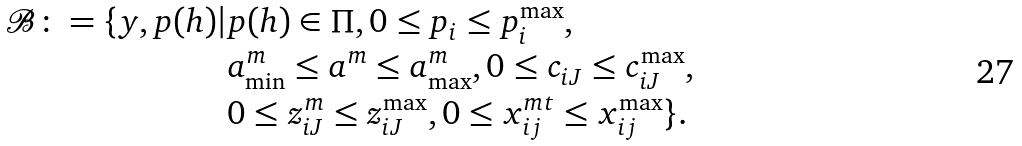Convert formula to latex. <formula><loc_0><loc_0><loc_500><loc_500>\mathcal { B } \colon = \{ y , p ( h ) | & p ( h ) \in \Pi , 0 \leq p _ { i } \leq p ^ { \max } _ { i } , \\ & a ^ { m } _ { \min } \leq a ^ { m } \leq a ^ { m } _ { \max } , 0 \leq c _ { i J } \leq c ^ { \max } _ { i J } , \\ & 0 \leq z ^ { m } _ { i J } \leq z ^ { \max } _ { i J } , 0 \leq x _ { i j } ^ { m t } \leq x ^ { \max } _ { i j } \} .</formula> 